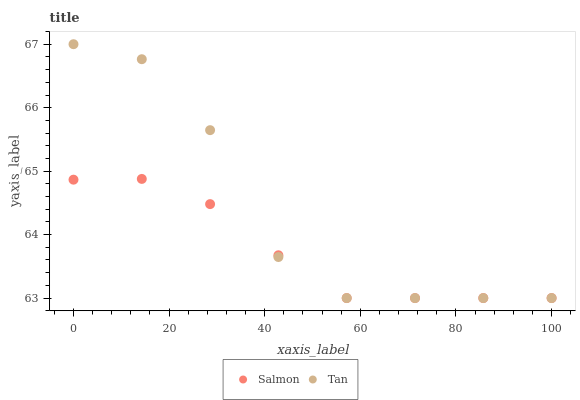Does Salmon have the minimum area under the curve?
Answer yes or no. Yes. Does Tan have the maximum area under the curve?
Answer yes or no. Yes. Does Salmon have the maximum area under the curve?
Answer yes or no. No. Is Salmon the smoothest?
Answer yes or no. Yes. Is Tan the roughest?
Answer yes or no. Yes. Is Salmon the roughest?
Answer yes or no. No. Does Tan have the lowest value?
Answer yes or no. Yes. Does Tan have the highest value?
Answer yes or no. Yes. Does Salmon have the highest value?
Answer yes or no. No. Does Tan intersect Salmon?
Answer yes or no. Yes. Is Tan less than Salmon?
Answer yes or no. No. Is Tan greater than Salmon?
Answer yes or no. No. 